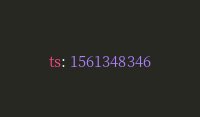<code> <loc_0><loc_0><loc_500><loc_500><_YAML_>ts: 1561348346
</code> 